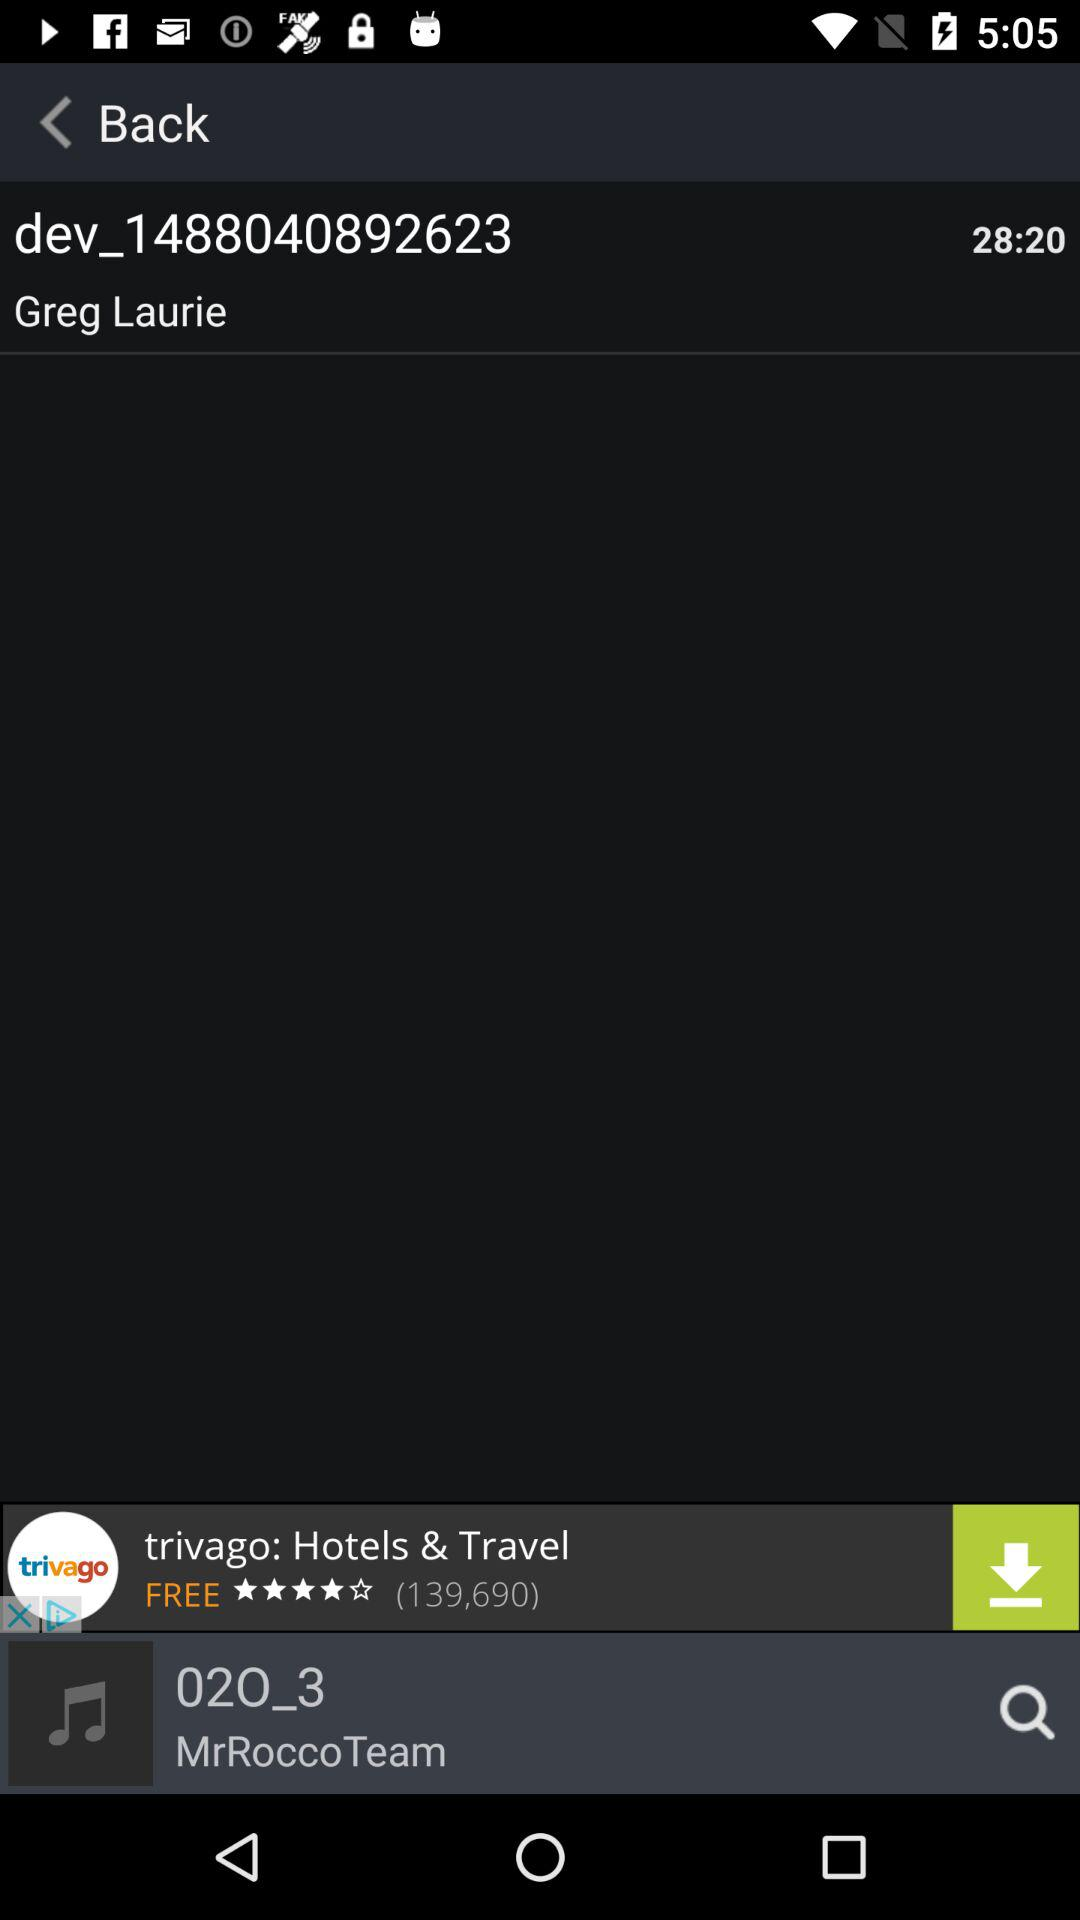What is the duration of "dev_1488040892623"? The duration of "dev_1488040892623" is 28 minutes 20 seconds. 